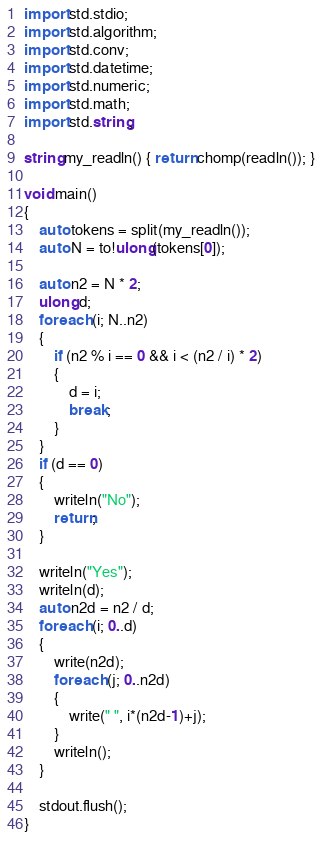Convert code to text. <code><loc_0><loc_0><loc_500><loc_500><_D_>import std.stdio;
import std.algorithm;
import std.conv;
import std.datetime;
import std.numeric;
import std.math;
import std.string;

string my_readln() { return chomp(readln()); }

void main()
{
	auto tokens = split(my_readln());
	auto N = to!ulong(tokens[0]);

	auto n2 = N * 2;
	ulong d;
	foreach (i; N..n2)
	{
		if (n2 % i == 0 && i < (n2 / i) * 2)
		{
			d = i;
			break;
		}
	}
	if (d == 0)
	{
		writeln("No");
		return;
	}

	writeln("Yes");
	writeln(d);
	auto n2d = n2 / d;
	foreach (i; 0..d)
	{
		write(n2d);
		foreach (j; 0..n2d)
		{
			write(" ", i*(n2d-1)+j);
		}
		writeln();
	}
	
	stdout.flush();
}</code> 